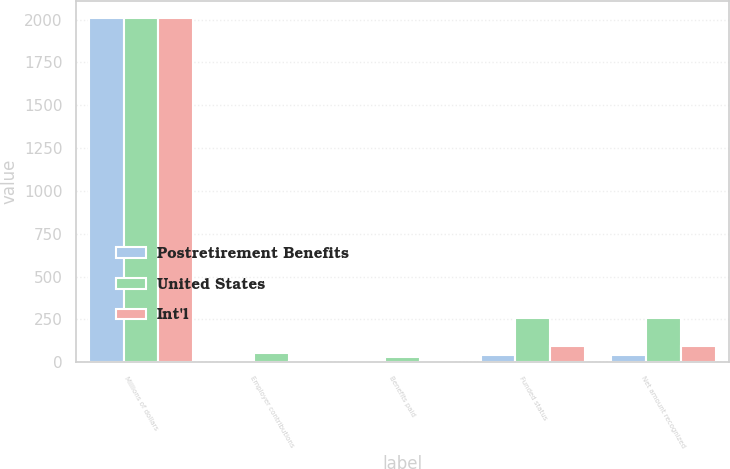<chart> <loc_0><loc_0><loc_500><loc_500><stacked_bar_chart><ecel><fcel>Millions of dollars<fcel>Employer contributions<fcel>Benefits paid<fcel>Funded status<fcel>Net amount recognized<nl><fcel>Postretirement Benefits<fcel>2008<fcel>1<fcel>9<fcel>42<fcel>42<nl><fcel>United States<fcel>2008<fcel>51<fcel>28<fcel>260<fcel>260<nl><fcel>Int'l<fcel>2008<fcel>7<fcel>12<fcel>92<fcel>92<nl></chart> 